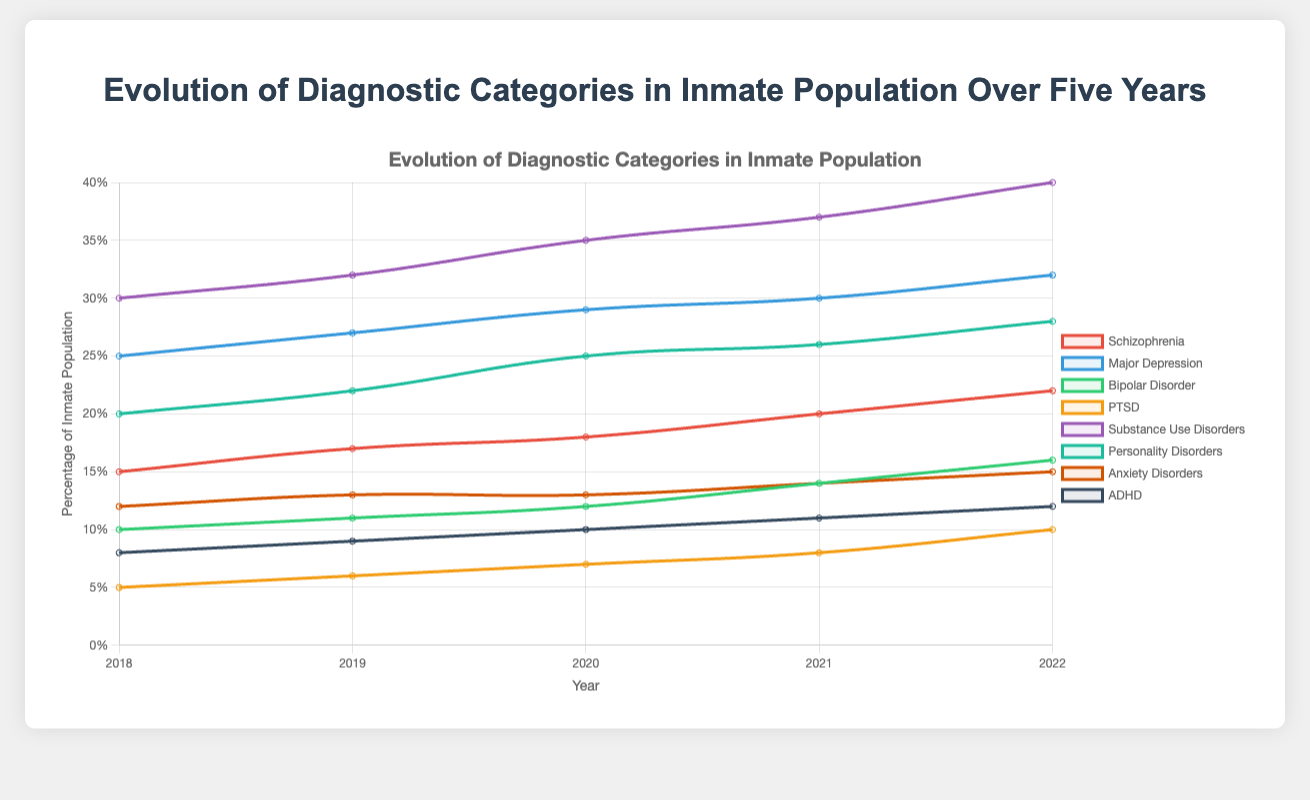What is the trend of Schizophrenia diagnosis over five years? The trend of Schizophrenia can be observed by looking at the data points for each year. From 2018 to 2022, the values are 15, 17, 18, 20, and 22 respectively, showing a consistent increase each year.
Answer: Increasing Which mental health disorder had the highest percentage of inmate population in 2022? To determine which disorder had the highest percentage in 2022, compare the values for all disorders in that year. Substance Use Disorders had the highest value with 40%.
Answer: Substance Use Disorders How many more inmates were diagnosed with Major Depression than Anxiety Disorders in 2022? To find the difference between inmates diagnosed with Major Depression and Anxiety Disorders in 2022, subtract the percentage of Anxiety Disorders (15) from Major Depression (32). 32 - 15 = 17.
Answer: 17 Which disorders remained consistent or had the least change over the five years? Look at the slope of the lines for each disorder. Anxiety Disorders had the most consistent data points (12, 13, 13, 14, and 15) over the five years, indicating the least change.
Answer: Anxiety Disorders What is the average percentage of inmates with Schizophrenia over the five-year period? Calculate the average by summing the five values for Schizophrenia and then dividing by the number of years. (15 + 17 + 18 + 20 + 22) / 5 = 92 / 5 = 18.4.
Answer: 18.4 Which disorder showed the fastest growth in percentage of the inmate population from 2018 to 2022? To determine the fastest growth, calculate the difference between the values from 2018 to 2022 for each disorder. PTSD increased from 5 to 10 which is a 100% growth rate.
Answer: PTSD How does the percentage of inmates diagnosed with ADHD in 2018 compare to those in 2022? Compare the values of ADHD for 2018 and 2022. In 2018, it was 8 and in 2022, it was 12, showing an increase of 4 percentage points.
Answer: Increased by 4 Which disorder had the smallest increase in percentage from 2021 to 2022? Look at the increase from 2021 to 2022 for each disorder. The smallest increase was in Anxiety Disorders, which went from 14 to 15, an increase of only 1 percentage point.
Answer: Anxiety Disorders What was the combined percentage of inmates diagnosed with Schizophrenia and Major Depression in 2020? Add the values of Schizophrenia (18) and Major Depression (29) for the year 2020. 18 + 29 = 47.
Answer: 47 Which disorder had the second largest percentage of inmates in 2021, and what was the percentage? Identify the disorder with the second largest value in 2021 by comparing the values. Substance Use Disorders had the highest (37), and Major Depression had the second largest with 30%.
Answer: Major Depression, 30% 